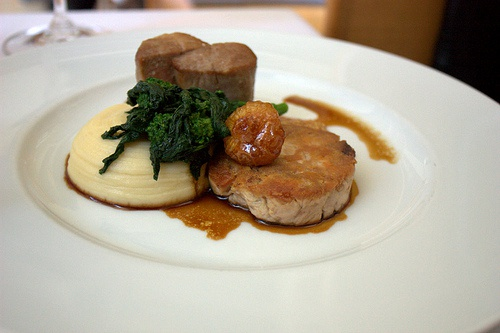Describe the objects in this image and their specific colors. I can see broccoli in tan, black, and darkgreen tones and wine glass in tan, darkgray, and lightgray tones in this image. 